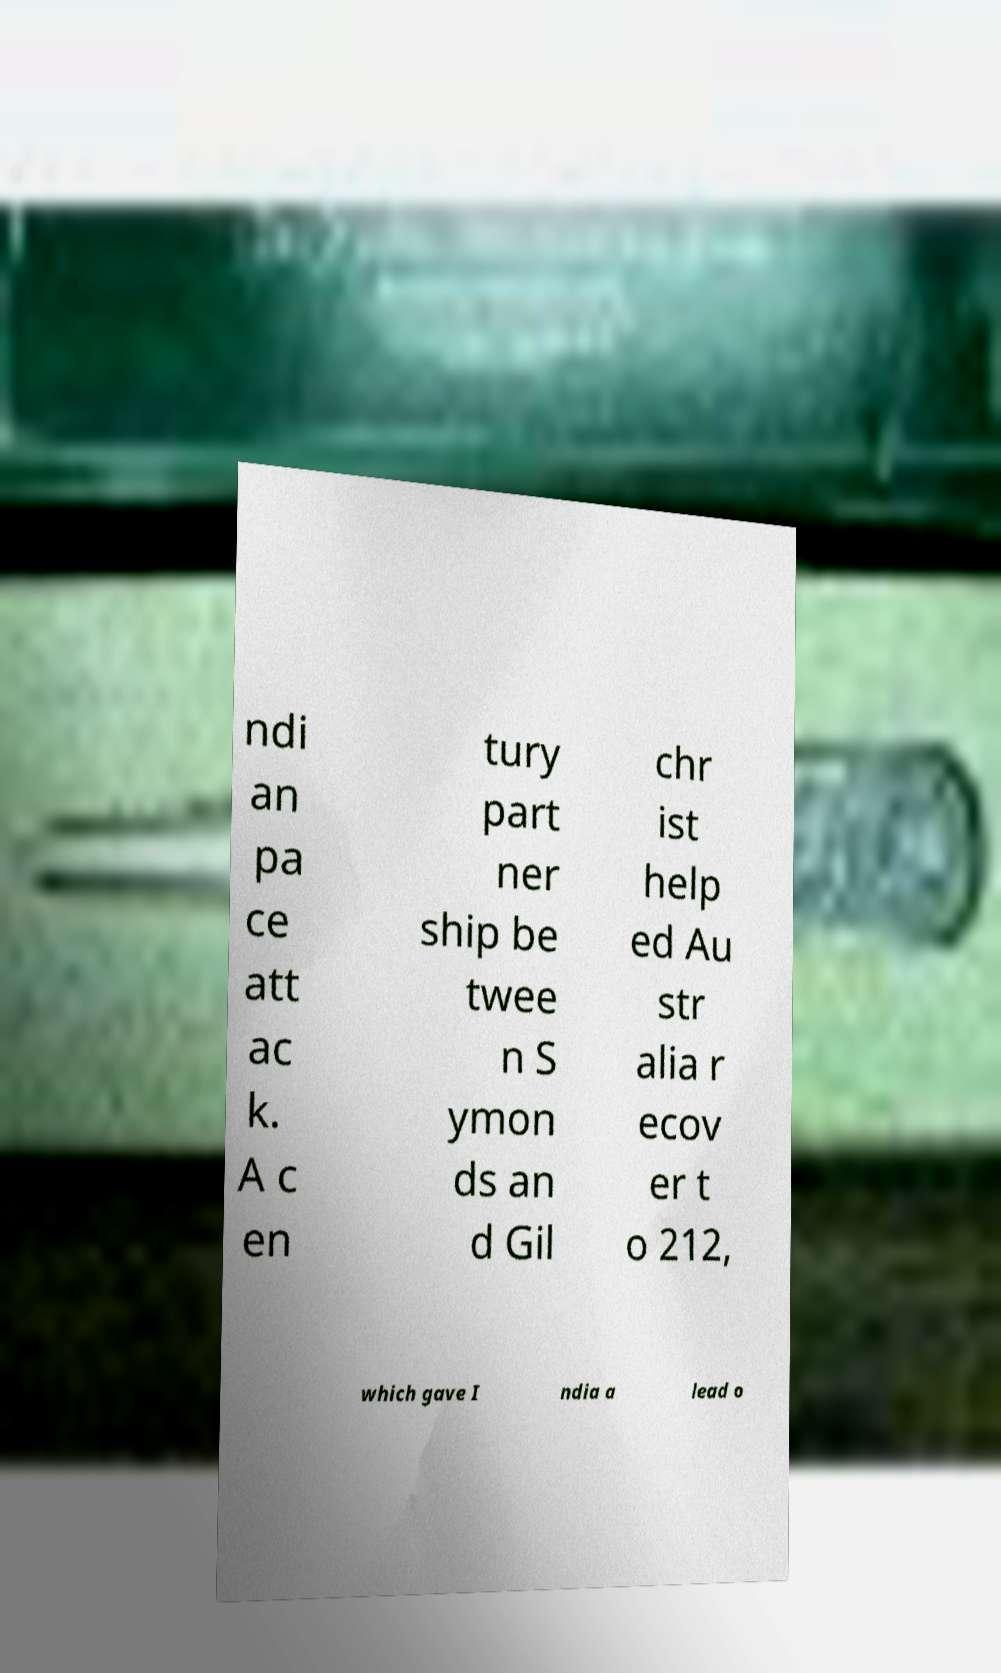Could you assist in decoding the text presented in this image and type it out clearly? ndi an pa ce att ac k. A c en tury part ner ship be twee n S ymon ds an d Gil chr ist help ed Au str alia r ecov er t o 212, which gave I ndia a lead o 